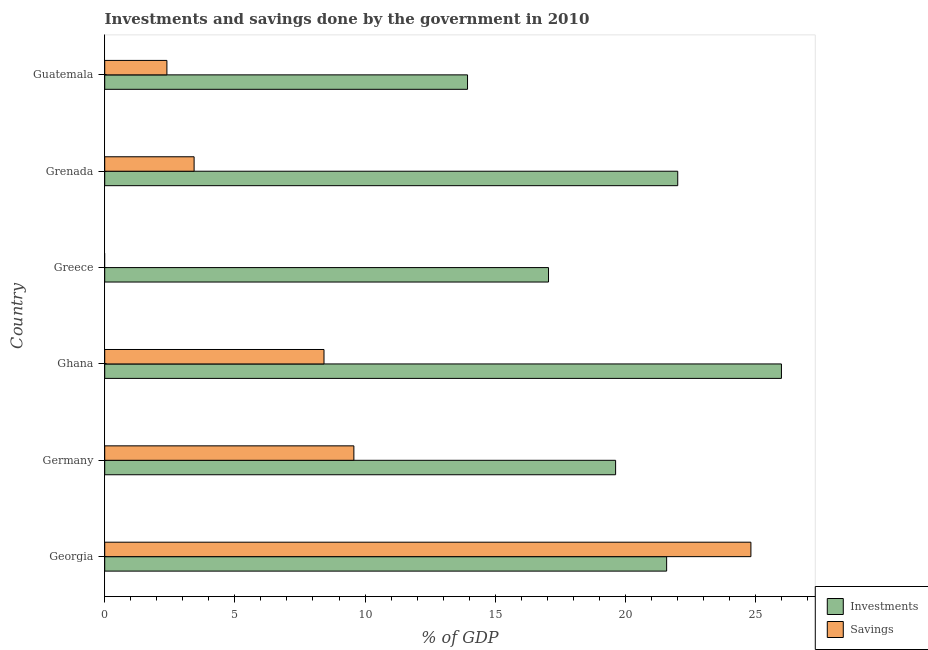Are the number of bars on each tick of the Y-axis equal?
Your answer should be compact. No. How many bars are there on the 6th tick from the top?
Provide a short and direct response. 2. What is the label of the 6th group of bars from the top?
Your response must be concise. Georgia. What is the savings of government in Grenada?
Offer a very short reply. 3.43. Across all countries, what is the maximum investments of government?
Your answer should be very brief. 26. Across all countries, what is the minimum savings of government?
Give a very brief answer. 0. In which country was the savings of government maximum?
Provide a succinct answer. Georgia. What is the total investments of government in the graph?
Keep it short and to the point. 120.21. What is the difference between the investments of government in Greece and that in Guatemala?
Your response must be concise. 3.11. What is the difference between the savings of government in Ghana and the investments of government in Greece?
Your response must be concise. -8.62. What is the average investments of government per country?
Make the answer very short. 20.03. What is the difference between the investments of government and savings of government in Georgia?
Offer a terse response. -3.24. What is the ratio of the savings of government in Germany to that in Ghana?
Ensure brevity in your answer.  1.14. Is the savings of government in Georgia less than that in Grenada?
Your answer should be compact. No. Is the difference between the savings of government in Grenada and Guatemala greater than the difference between the investments of government in Grenada and Guatemala?
Ensure brevity in your answer.  No. What is the difference between the highest and the second highest savings of government?
Give a very brief answer. 15.25. What is the difference between the highest and the lowest savings of government?
Keep it short and to the point. 24.82. In how many countries, is the investments of government greater than the average investments of government taken over all countries?
Your answer should be very brief. 3. Is the sum of the investments of government in Georgia and Ghana greater than the maximum savings of government across all countries?
Provide a short and direct response. Yes. How many bars are there?
Make the answer very short. 11. Are all the bars in the graph horizontal?
Offer a terse response. Yes. What is the difference between two consecutive major ticks on the X-axis?
Ensure brevity in your answer.  5. Are the values on the major ticks of X-axis written in scientific E-notation?
Your answer should be very brief. No. Does the graph contain any zero values?
Ensure brevity in your answer.  Yes. Does the graph contain grids?
Give a very brief answer. No. How many legend labels are there?
Offer a terse response. 2. How are the legend labels stacked?
Keep it short and to the point. Vertical. What is the title of the graph?
Give a very brief answer. Investments and savings done by the government in 2010. What is the label or title of the X-axis?
Your response must be concise. % of GDP. What is the % of GDP in Investments in Georgia?
Your answer should be compact. 21.59. What is the % of GDP in Savings in Georgia?
Make the answer very short. 24.82. What is the % of GDP in Investments in Germany?
Provide a short and direct response. 19.63. What is the % of GDP of Savings in Germany?
Provide a succinct answer. 9.57. What is the % of GDP in Investments in Ghana?
Provide a short and direct response. 26. What is the % of GDP of Savings in Ghana?
Keep it short and to the point. 8.42. What is the % of GDP of Investments in Greece?
Make the answer very short. 17.05. What is the % of GDP of Investments in Grenada?
Ensure brevity in your answer.  22.01. What is the % of GDP of Savings in Grenada?
Your response must be concise. 3.43. What is the % of GDP in Investments in Guatemala?
Offer a terse response. 13.94. What is the % of GDP in Savings in Guatemala?
Give a very brief answer. 2.39. Across all countries, what is the maximum % of GDP of Investments?
Keep it short and to the point. 26. Across all countries, what is the maximum % of GDP of Savings?
Your answer should be compact. 24.82. Across all countries, what is the minimum % of GDP of Investments?
Your answer should be very brief. 13.94. What is the total % of GDP in Investments in the graph?
Provide a succinct answer. 120.21. What is the total % of GDP of Savings in the graph?
Make the answer very short. 48.64. What is the difference between the % of GDP of Investments in Georgia and that in Germany?
Offer a very short reply. 1.96. What is the difference between the % of GDP in Savings in Georgia and that in Germany?
Give a very brief answer. 15.25. What is the difference between the % of GDP of Investments in Georgia and that in Ghana?
Keep it short and to the point. -4.41. What is the difference between the % of GDP of Savings in Georgia and that in Ghana?
Provide a succinct answer. 16.4. What is the difference between the % of GDP in Investments in Georgia and that in Greece?
Provide a short and direct response. 4.54. What is the difference between the % of GDP of Investments in Georgia and that in Grenada?
Provide a succinct answer. -0.43. What is the difference between the % of GDP of Savings in Georgia and that in Grenada?
Your answer should be very brief. 21.39. What is the difference between the % of GDP in Investments in Georgia and that in Guatemala?
Your response must be concise. 7.65. What is the difference between the % of GDP in Savings in Georgia and that in Guatemala?
Make the answer very short. 22.43. What is the difference between the % of GDP in Investments in Germany and that in Ghana?
Keep it short and to the point. -6.37. What is the difference between the % of GDP in Savings in Germany and that in Ghana?
Offer a very short reply. 1.15. What is the difference between the % of GDP of Investments in Germany and that in Greece?
Give a very brief answer. 2.58. What is the difference between the % of GDP of Investments in Germany and that in Grenada?
Keep it short and to the point. -2.39. What is the difference between the % of GDP of Savings in Germany and that in Grenada?
Your answer should be very brief. 6.14. What is the difference between the % of GDP of Investments in Germany and that in Guatemala?
Offer a terse response. 5.69. What is the difference between the % of GDP in Savings in Germany and that in Guatemala?
Provide a succinct answer. 7.18. What is the difference between the % of GDP in Investments in Ghana and that in Greece?
Provide a succinct answer. 8.95. What is the difference between the % of GDP of Investments in Ghana and that in Grenada?
Make the answer very short. 3.98. What is the difference between the % of GDP in Savings in Ghana and that in Grenada?
Offer a terse response. 4.99. What is the difference between the % of GDP in Investments in Ghana and that in Guatemala?
Make the answer very short. 12.06. What is the difference between the % of GDP in Savings in Ghana and that in Guatemala?
Your answer should be compact. 6.03. What is the difference between the % of GDP in Investments in Greece and that in Grenada?
Your answer should be compact. -4.96. What is the difference between the % of GDP in Investments in Greece and that in Guatemala?
Offer a very short reply. 3.11. What is the difference between the % of GDP of Investments in Grenada and that in Guatemala?
Provide a succinct answer. 8.07. What is the difference between the % of GDP in Savings in Grenada and that in Guatemala?
Give a very brief answer. 1.05. What is the difference between the % of GDP of Investments in Georgia and the % of GDP of Savings in Germany?
Give a very brief answer. 12.01. What is the difference between the % of GDP of Investments in Georgia and the % of GDP of Savings in Ghana?
Your answer should be very brief. 13.16. What is the difference between the % of GDP in Investments in Georgia and the % of GDP in Savings in Grenada?
Your answer should be very brief. 18.15. What is the difference between the % of GDP of Investments in Georgia and the % of GDP of Savings in Guatemala?
Offer a terse response. 19.2. What is the difference between the % of GDP of Investments in Germany and the % of GDP of Savings in Ghana?
Offer a very short reply. 11.2. What is the difference between the % of GDP of Investments in Germany and the % of GDP of Savings in Grenada?
Your answer should be very brief. 16.19. What is the difference between the % of GDP in Investments in Germany and the % of GDP in Savings in Guatemala?
Give a very brief answer. 17.24. What is the difference between the % of GDP of Investments in Ghana and the % of GDP of Savings in Grenada?
Provide a short and direct response. 22.56. What is the difference between the % of GDP of Investments in Ghana and the % of GDP of Savings in Guatemala?
Make the answer very short. 23.61. What is the difference between the % of GDP of Investments in Greece and the % of GDP of Savings in Grenada?
Your answer should be compact. 13.61. What is the difference between the % of GDP of Investments in Greece and the % of GDP of Savings in Guatemala?
Ensure brevity in your answer.  14.66. What is the difference between the % of GDP in Investments in Grenada and the % of GDP in Savings in Guatemala?
Ensure brevity in your answer.  19.62. What is the average % of GDP of Investments per country?
Ensure brevity in your answer.  20.03. What is the average % of GDP of Savings per country?
Your response must be concise. 8.11. What is the difference between the % of GDP in Investments and % of GDP in Savings in Georgia?
Your answer should be compact. -3.24. What is the difference between the % of GDP of Investments and % of GDP of Savings in Germany?
Offer a terse response. 10.05. What is the difference between the % of GDP in Investments and % of GDP in Savings in Ghana?
Give a very brief answer. 17.57. What is the difference between the % of GDP of Investments and % of GDP of Savings in Grenada?
Keep it short and to the point. 18.58. What is the difference between the % of GDP in Investments and % of GDP in Savings in Guatemala?
Give a very brief answer. 11.55. What is the ratio of the % of GDP of Investments in Georgia to that in Germany?
Offer a terse response. 1.1. What is the ratio of the % of GDP of Savings in Georgia to that in Germany?
Keep it short and to the point. 2.59. What is the ratio of the % of GDP of Investments in Georgia to that in Ghana?
Provide a succinct answer. 0.83. What is the ratio of the % of GDP in Savings in Georgia to that in Ghana?
Offer a very short reply. 2.95. What is the ratio of the % of GDP in Investments in Georgia to that in Greece?
Offer a very short reply. 1.27. What is the ratio of the % of GDP in Investments in Georgia to that in Grenada?
Provide a short and direct response. 0.98. What is the ratio of the % of GDP in Savings in Georgia to that in Grenada?
Ensure brevity in your answer.  7.23. What is the ratio of the % of GDP of Investments in Georgia to that in Guatemala?
Your answer should be very brief. 1.55. What is the ratio of the % of GDP of Savings in Georgia to that in Guatemala?
Your answer should be compact. 10.39. What is the ratio of the % of GDP of Investments in Germany to that in Ghana?
Make the answer very short. 0.75. What is the ratio of the % of GDP of Savings in Germany to that in Ghana?
Provide a short and direct response. 1.14. What is the ratio of the % of GDP of Investments in Germany to that in Greece?
Provide a succinct answer. 1.15. What is the ratio of the % of GDP of Investments in Germany to that in Grenada?
Offer a terse response. 0.89. What is the ratio of the % of GDP of Savings in Germany to that in Grenada?
Keep it short and to the point. 2.79. What is the ratio of the % of GDP of Investments in Germany to that in Guatemala?
Your answer should be very brief. 1.41. What is the ratio of the % of GDP in Savings in Germany to that in Guatemala?
Your answer should be compact. 4.01. What is the ratio of the % of GDP of Investments in Ghana to that in Greece?
Give a very brief answer. 1.52. What is the ratio of the % of GDP in Investments in Ghana to that in Grenada?
Make the answer very short. 1.18. What is the ratio of the % of GDP of Savings in Ghana to that in Grenada?
Provide a succinct answer. 2.45. What is the ratio of the % of GDP of Investments in Ghana to that in Guatemala?
Keep it short and to the point. 1.87. What is the ratio of the % of GDP in Savings in Ghana to that in Guatemala?
Your response must be concise. 3.53. What is the ratio of the % of GDP in Investments in Greece to that in Grenada?
Ensure brevity in your answer.  0.77. What is the ratio of the % of GDP of Investments in Greece to that in Guatemala?
Keep it short and to the point. 1.22. What is the ratio of the % of GDP in Investments in Grenada to that in Guatemala?
Give a very brief answer. 1.58. What is the ratio of the % of GDP in Savings in Grenada to that in Guatemala?
Provide a succinct answer. 1.44. What is the difference between the highest and the second highest % of GDP of Investments?
Give a very brief answer. 3.98. What is the difference between the highest and the second highest % of GDP of Savings?
Your response must be concise. 15.25. What is the difference between the highest and the lowest % of GDP of Investments?
Provide a short and direct response. 12.06. What is the difference between the highest and the lowest % of GDP in Savings?
Make the answer very short. 24.82. 